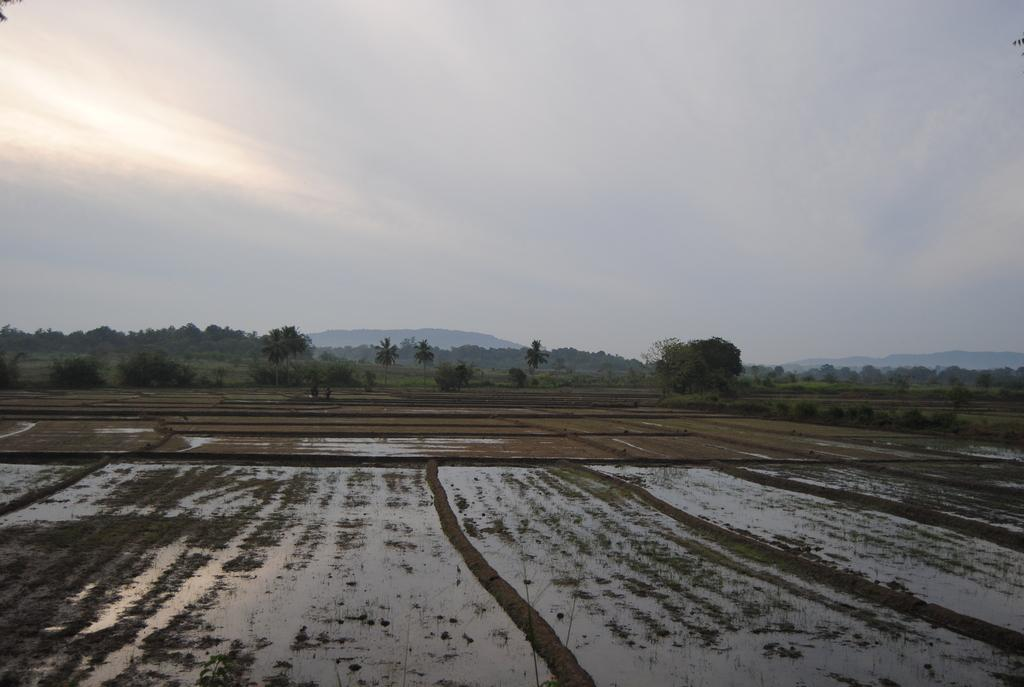What is visible in the front of the image? There is water in the front of the image. What can be seen in the background of the image? There are trees in the background of the image. How would you describe the sky in the image? The sky is cloudy in the image. How many cushions are floating on the water in the image? There are no cushions present in the image; it only features water, trees, and a cloudy sky. What type of pollution can be seen in the image? There is no pollution visible in the image; it only features water, trees, and a cloudy sky. 